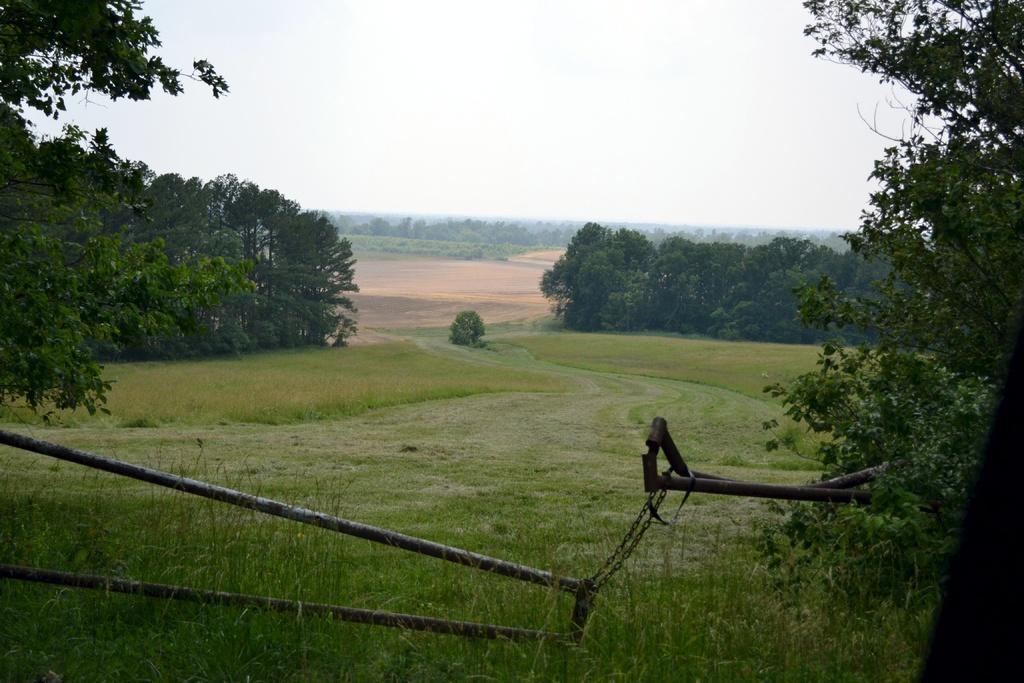How would you summarize this image in a sentence or two? In this image, I can see the trees with branches and leaves. This is the grass. It looks like an iron object. Here is the sky. 